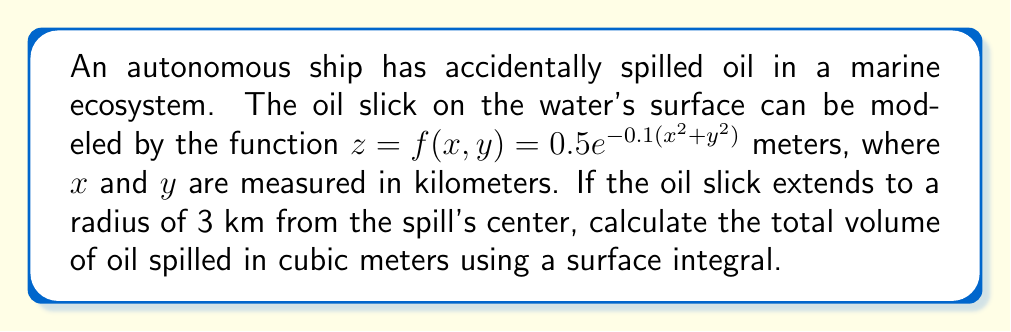Could you help me with this problem? To solve this problem, we'll use the following steps:

1) The volume under a surface $z = f(x,y)$ over a region $R$ is given by the surface integral:

   $$V = \iint_R f(x,y) \, dA$$

2) The region $R$ in this case is a circle with radius 3 km. It's easier to use polar coordinates for this integration. The transformation is:
   
   $x = r\cos\theta$
   $y = r\sin\theta$
   $dA = r \, dr \, d\theta$

3) In polar coordinates, the function becomes:

   $$f(r,\theta) = 0.5e^{-0.1r^2}$$

4) The integral in polar coordinates is:

   $$V = \int_0^{2\pi} \int_0^3 0.5e^{-0.1r^2} \cdot r \, dr \, d\theta$$

5) Simplify:

   $$V = \pi \int_0^3 re^{-0.1r^2} \, dr$$

6) To solve this, use $u$-substitution:
   Let $u = -0.1r^2$, then $du = -0.2r \, dr$, or $r \, dr = -5 \, du$

7) Changing the limits: when $r=0$, $u=0$; when $r=3$, $u=-0.9$

8) The integral becomes:

   $$V = -5\pi \int_{-0.9}^0 e^u \, du = -5\pi [e^u]_{-0.9}^0 = -5\pi(1 - e^{-0.9})$$

9) Evaluate:

   $$V \approx 13,823.6 \text{ m}^3$$
Answer: $13,823.6 \text{ m}^3$ 